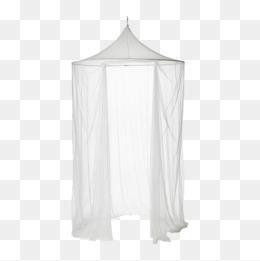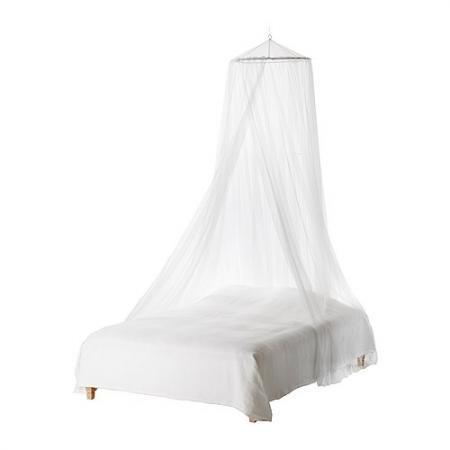The first image is the image on the left, the second image is the image on the right. Given the left and right images, does the statement "In the left image, all pillows are white." hold true? Answer yes or no. No. The first image is the image on the left, the second image is the image on the right. Evaluate the accuracy of this statement regarding the images: "Exactly one net is white.". Is it true? Answer yes or no. No. 